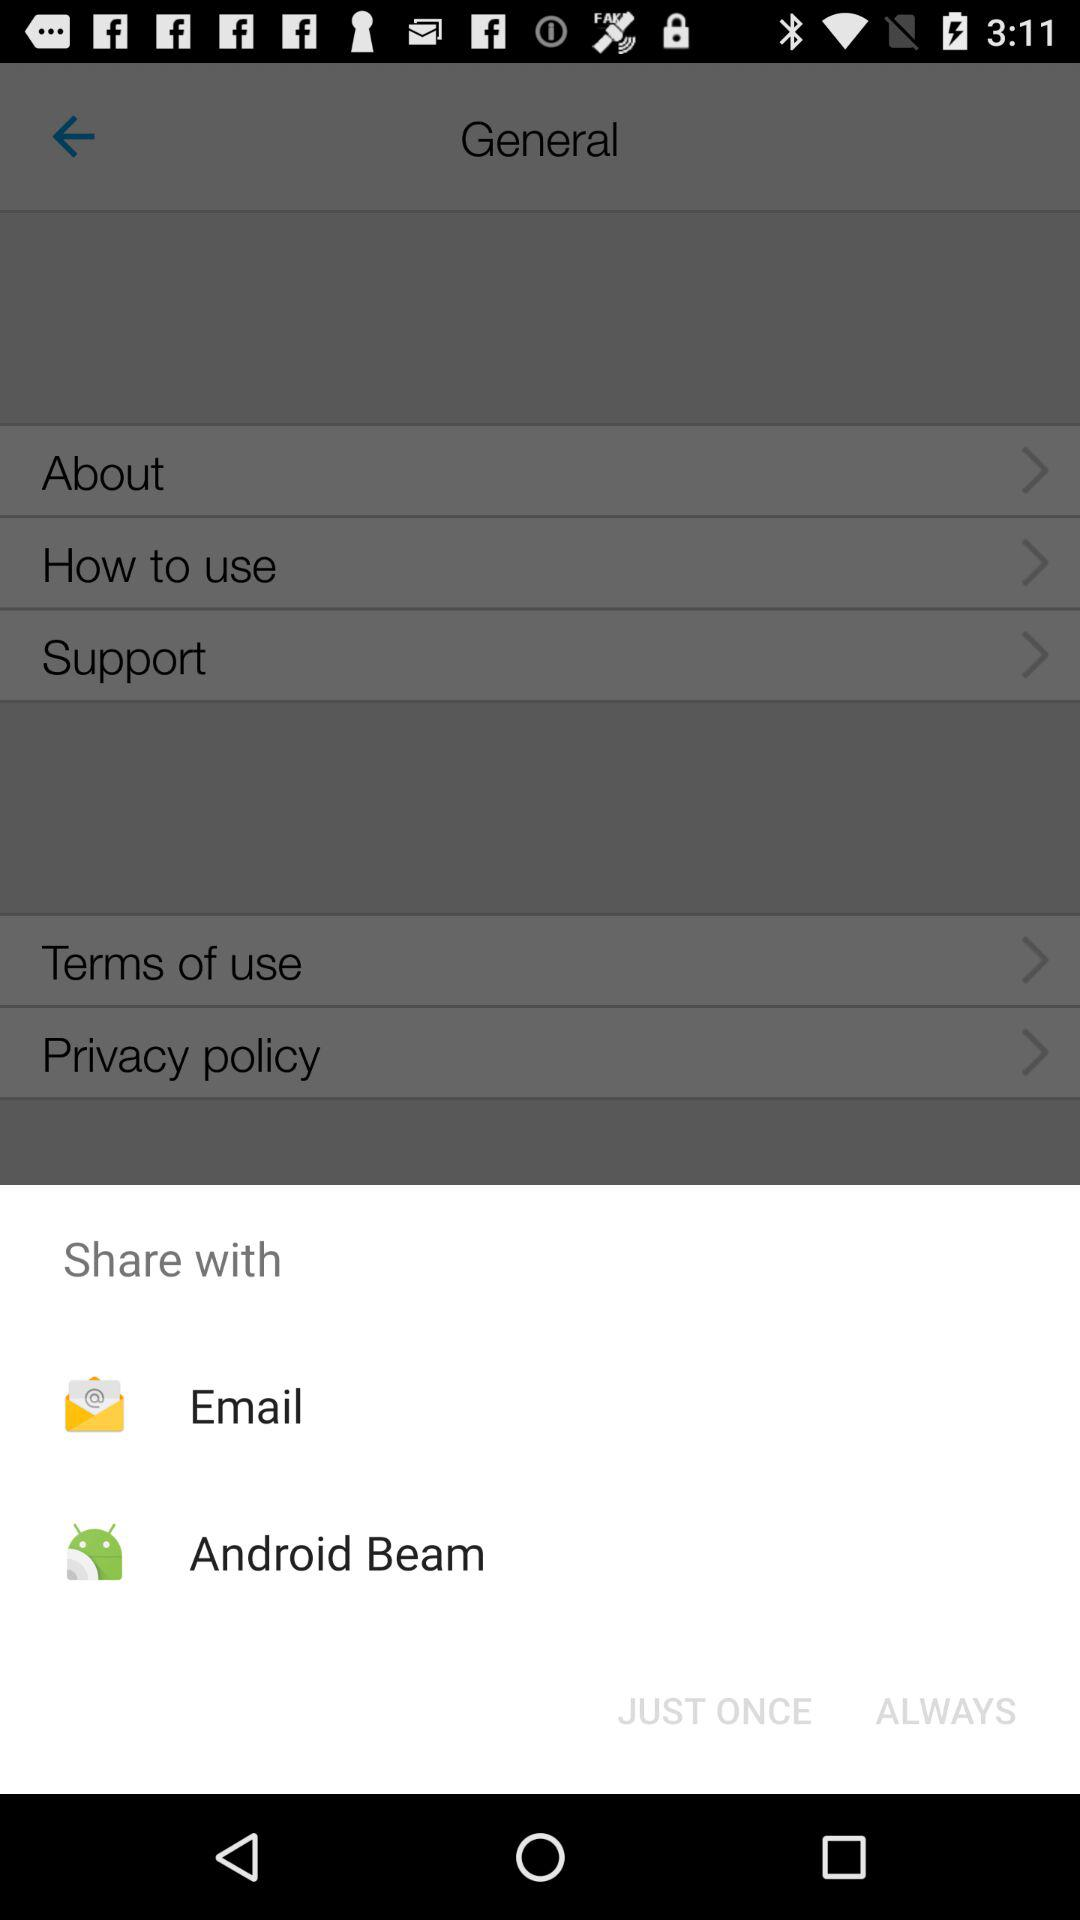What are the sharing options? The sharing options are "Email" and "Android Beam". 